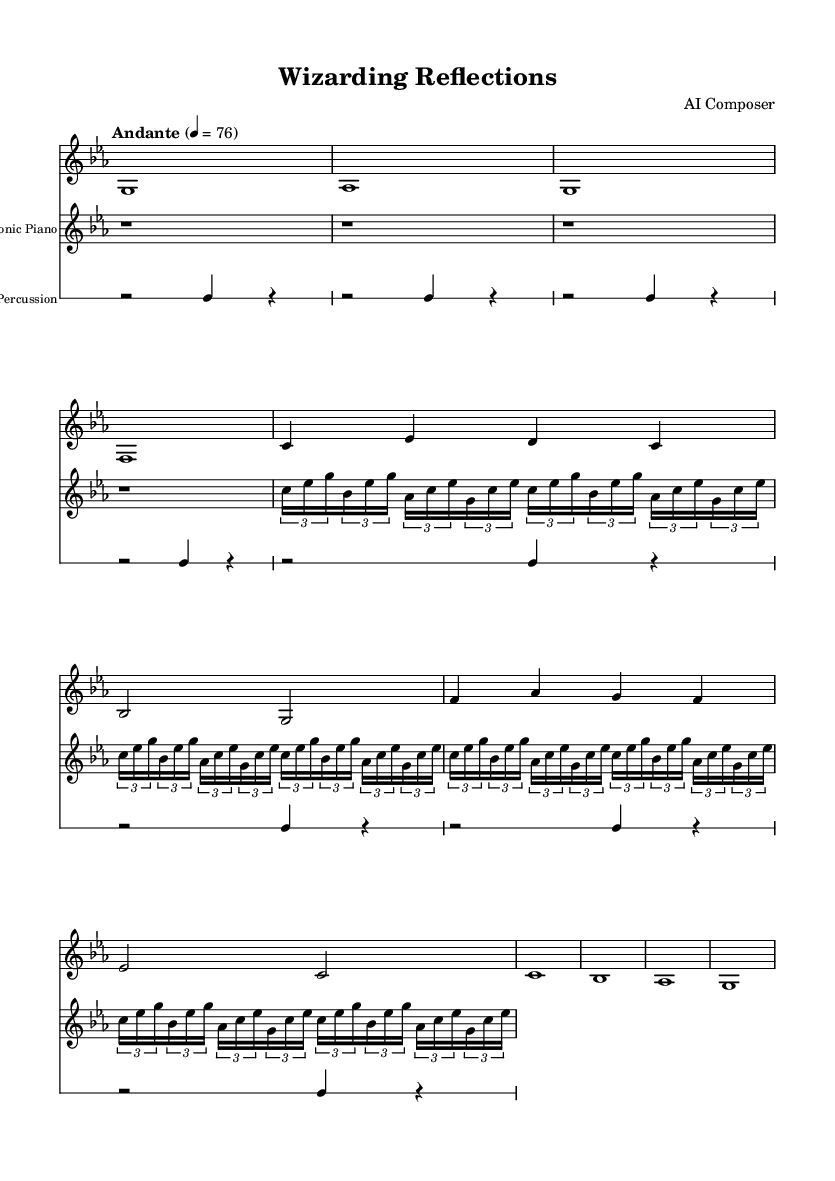What is the key signature of this music? The key signature indicates the piece is in C minor, which has three flats (B♭, E♭, and A♭).
Answer: C minor What is the time signature of this music? The time signature is specified as 4/4, meaning there are four beats in each measure.
Answer: 4/4 What is the tempo marking? The tempo marking is indicated as "Andante" with a metronome mark of quarter note equals 76, which suggests a moderately slow tempo.
Answer: Andante How many measures are present in the synth pad section? The synth pad section contains a total of eight measures; we can count the vertical lines separating each measure on the sheet.
Answer: 8 What instrument plays the ambient percussion? The ambient percussion is labeled in the score, indicating what instrument is used to create percussion sounds in the electronic setting.
Answer: Ambient Percussion What rhythmic pattern is used in the electronic piano part? The electronic piano part employs a tuple-based rhythmic pattern repeated eight times, indicating a specific grouping of notes in sixteenth note values.
Answer: Tuplet How does the synth pad contribute to the overall atmosphere of the piece? The synth pad's primarily sustained notes and gentle dynamics create a smooth, atmospheric backdrop that enhances the cinematic feel, typical for electronic soundscapes.
Answer: Smooth backdrop 